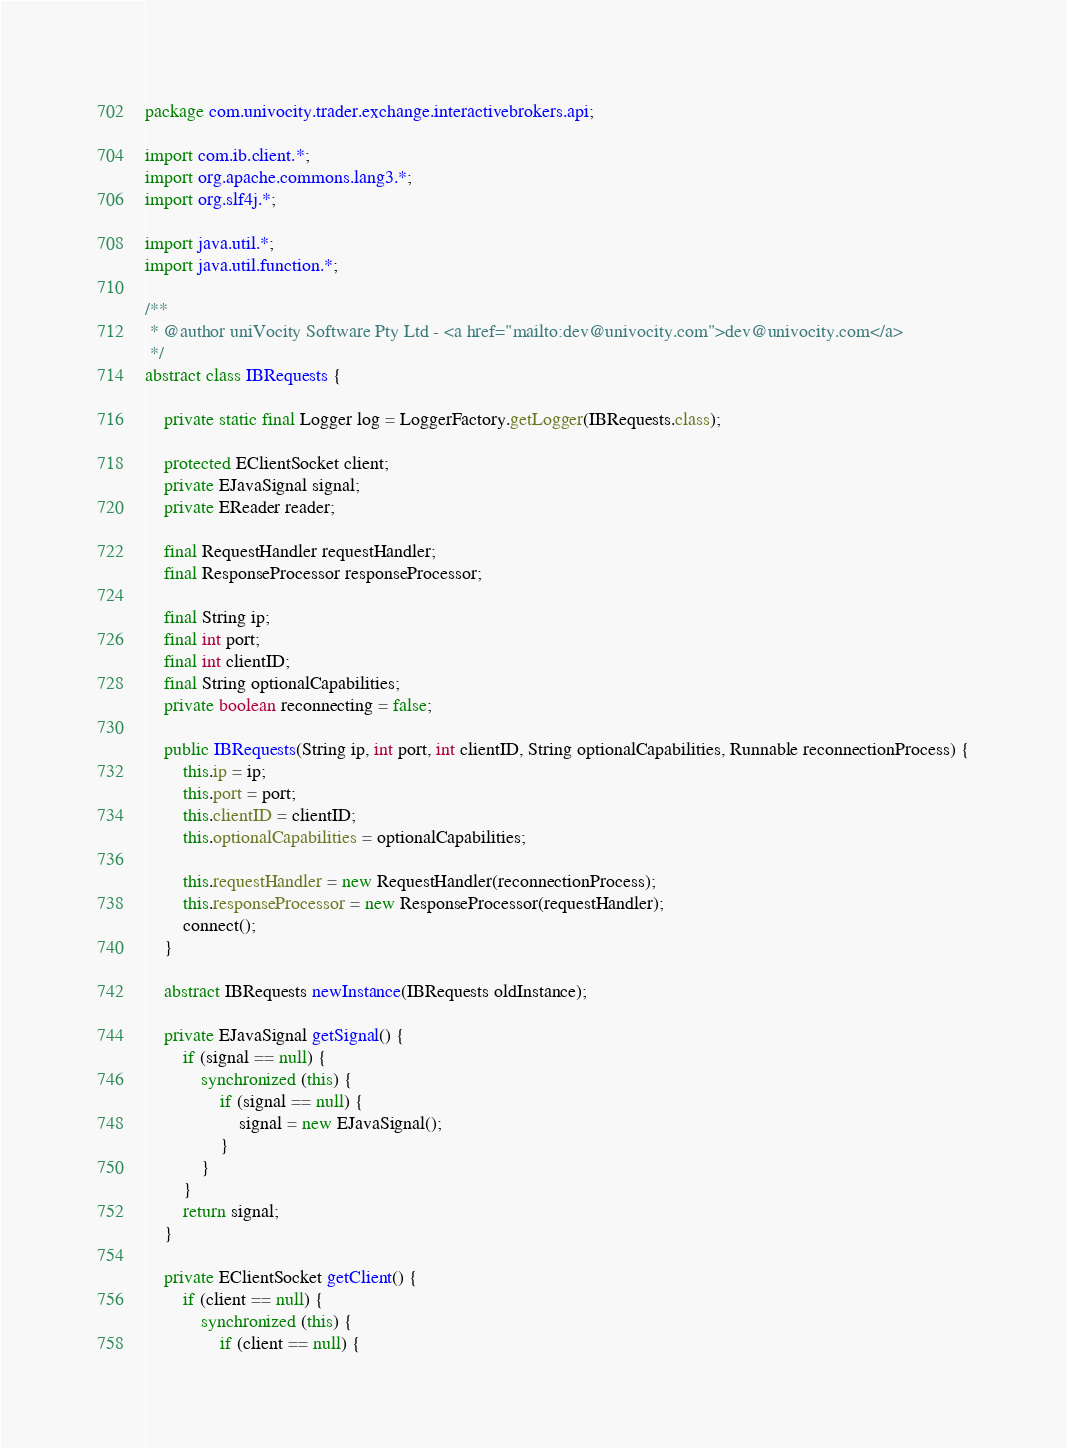<code> <loc_0><loc_0><loc_500><loc_500><_Java_>package com.univocity.trader.exchange.interactivebrokers.api;

import com.ib.client.*;
import org.apache.commons.lang3.*;
import org.slf4j.*;

import java.util.*;
import java.util.function.*;

/**
 * @author uniVocity Software Pty Ltd - <a href="mailto:dev@univocity.com">dev@univocity.com</a>
 */
abstract class IBRequests {

    private static final Logger log = LoggerFactory.getLogger(IBRequests.class);

    protected EClientSocket client;
    private EJavaSignal signal;
    private EReader reader;

    final RequestHandler requestHandler;
    final ResponseProcessor responseProcessor;

    final String ip;
    final int port;
    final int clientID;
    final String optionalCapabilities;
    private boolean reconnecting = false;

    public IBRequests(String ip, int port, int clientID, String optionalCapabilities, Runnable reconnectionProcess) {
        this.ip = ip;
        this.port = port;
        this.clientID = clientID;
        this.optionalCapabilities = optionalCapabilities;

        this.requestHandler = new RequestHandler(reconnectionProcess);
        this.responseProcessor = new ResponseProcessor(requestHandler);
        connect();
    }

    abstract IBRequests newInstance(IBRequests oldInstance);

    private EJavaSignal getSignal() {
        if (signal == null) {
            synchronized (this) {
                if (signal == null) {
                    signal = new EJavaSignal();
                }
            }
        }
        return signal;
    }

    private EClientSocket getClient() {
        if (client == null) {
            synchronized (this) {
                if (client == null) {</code> 